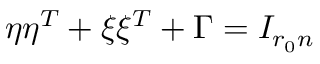<formula> <loc_0><loc_0><loc_500><loc_500>\eta \eta ^ { T } + \xi \xi ^ { T } + \Gamma = I _ { r _ { 0 } n }</formula> 